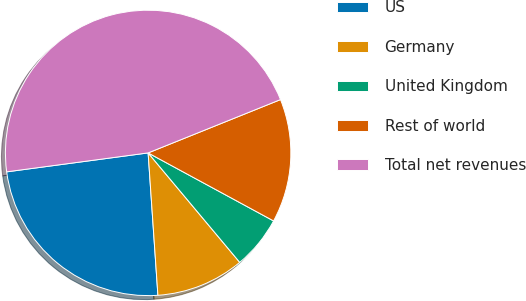Convert chart to OTSL. <chart><loc_0><loc_0><loc_500><loc_500><pie_chart><fcel>US<fcel>Germany<fcel>United Kingdom<fcel>Rest of world<fcel>Total net revenues<nl><fcel>23.97%<fcel>10.0%<fcel>6.0%<fcel>14.0%<fcel>46.02%<nl></chart> 